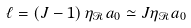<formula> <loc_0><loc_0><loc_500><loc_500>\ell = \left ( J - 1 \right ) \eta _ { \mathcal { R } } a _ { 0 } \simeq J \eta _ { \mathcal { R } } a _ { 0 }</formula> 